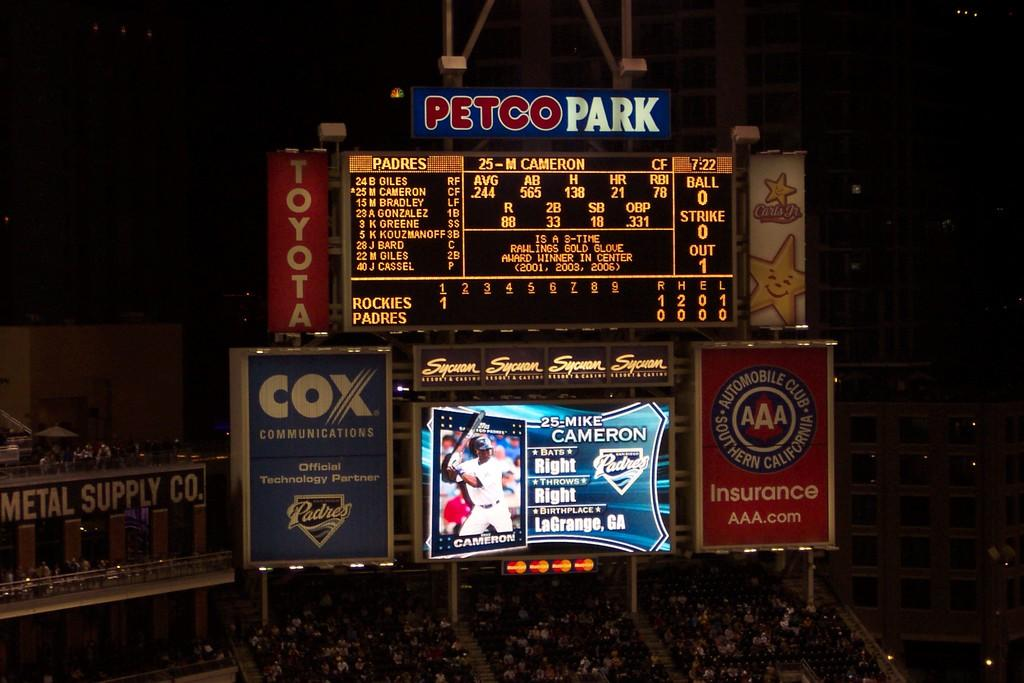<image>
Write a terse but informative summary of the picture. A large outdoor electronic display board with the title Petco Park. 